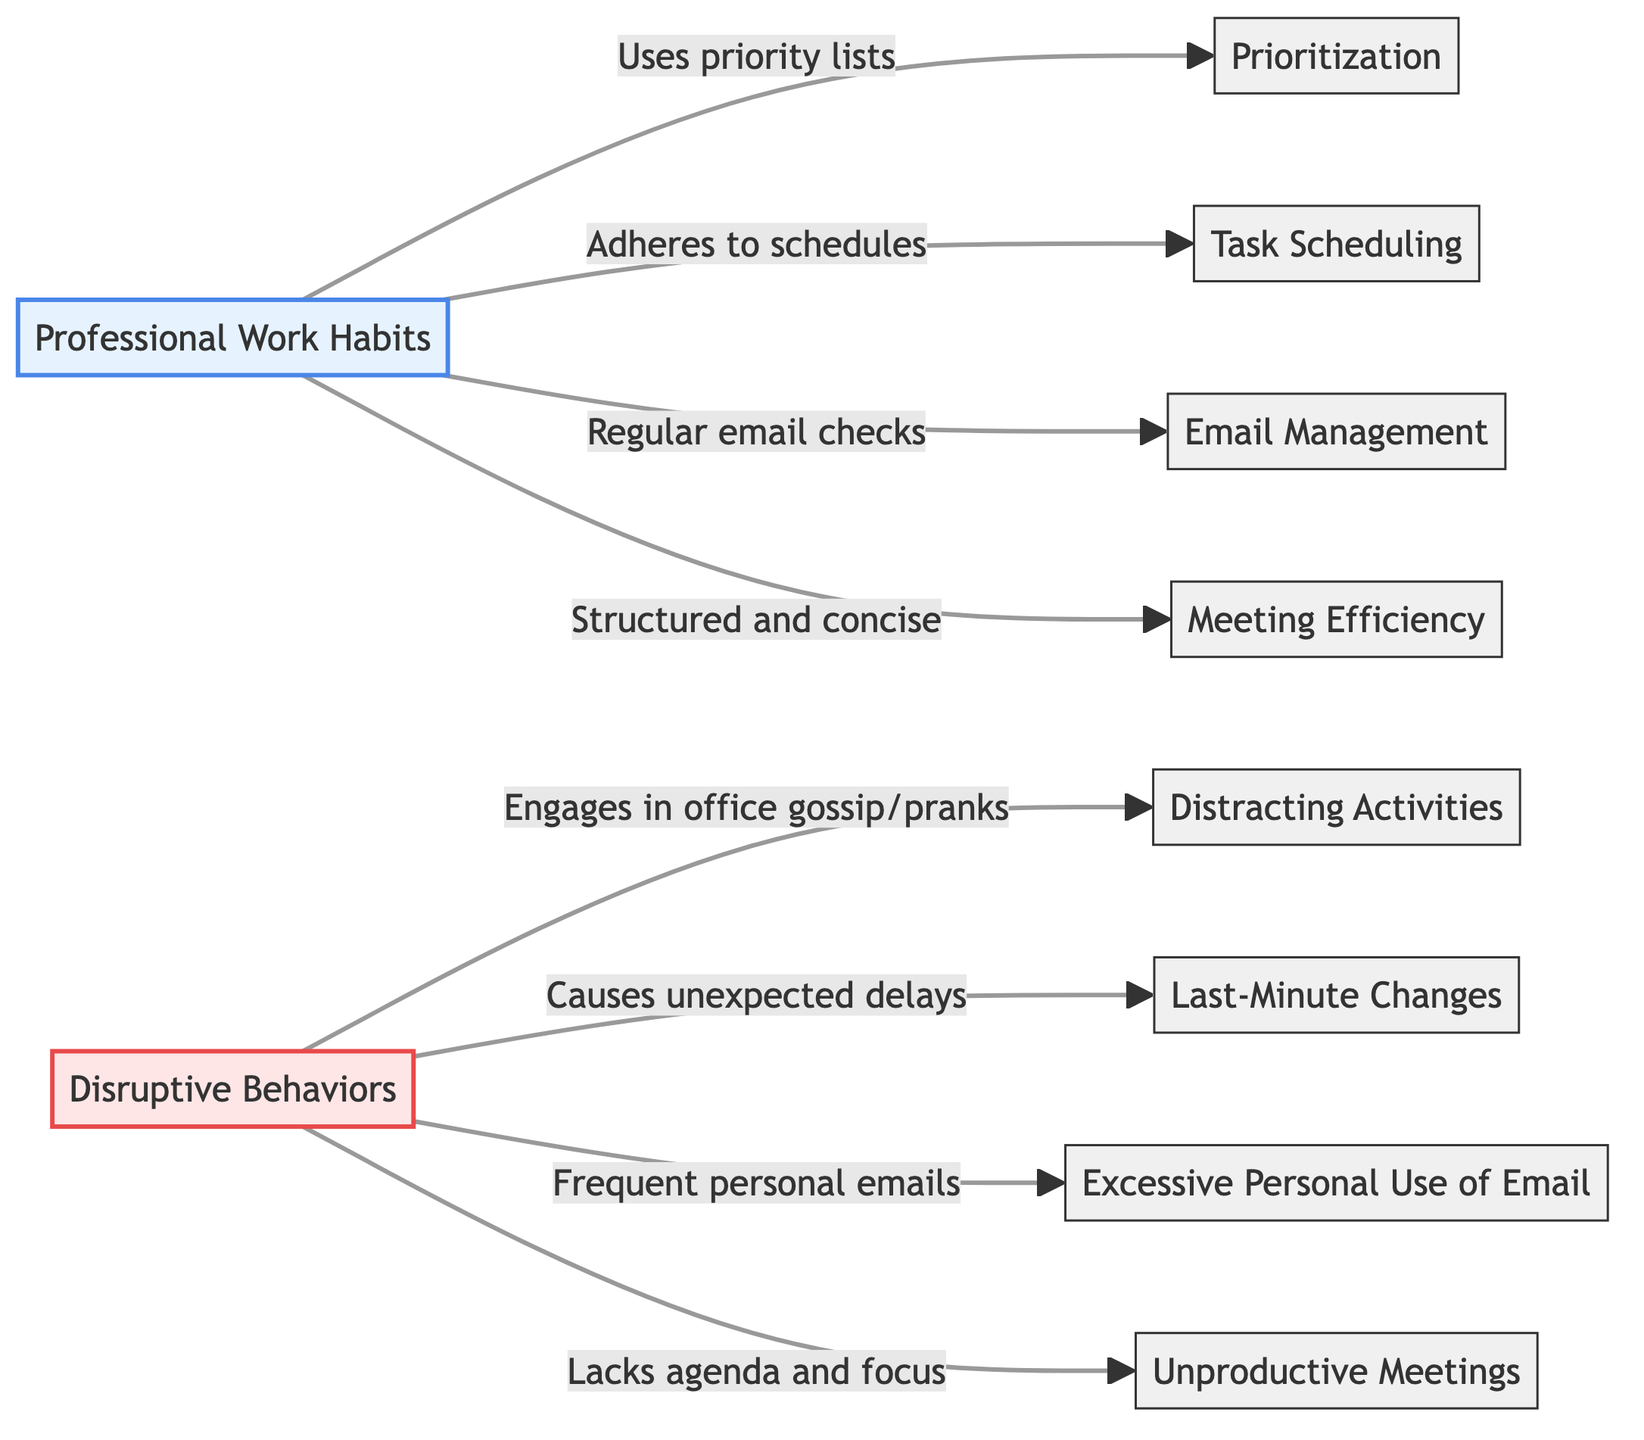What are the two main categories shown in the diagram? The diagram categorizes behaviors into "Professional Work Habits" and "Disruptive Behaviors." These represent the contrasting approaches to work within the workplace context.
Answer: Professional Work Habits, Disruptive Behaviors Which professional habit is associated with regular email checks? The diagram indicates that "Email Management" is the professional habit that corresponds to regular email checks. This is explicitly stated as part of the professional work habits.
Answer: Email Management How many specific habits and behaviors are illustrated in total? There are six professional work habits and four disruptive behaviors illustrated, adding up to a total of ten specific habits and behaviors in the diagram. This includes both categories combined.
Answer: Ten Which disruptive behavior is linked to unexpected delays? The diagram identifies "Last-Minute Changes" as the disruptive behavior that causes unexpected delays, showing how that specific behavior can be detrimental to workplace efficiency.
Answer: Last-Minute Changes What is the relationship between 'Prioritization' and 'Uses priority lists'? The diagram shows a direct association, stating that 'Prioritization' is a professional work habit that "Uses priority lists," indicating that this habit involves prioritizing tasks methodically.
Answer: Uses priority lists What type of meetings is indicated as unproductive? According to the diagram, 'Unproductive Meetings' are characterized by a "Lacks agenda and focus" relationship with disruptive behaviors, implying that these meetings do not effectively utilize time and resources.
Answer: Unproductive Meetings What connection exists between 'Task Scheduling' and professional habits? 'Task Scheduling' is depicted in the diagram as a professional work habit that relates to "Adheres to schedules." This connection highlights the importance of planning and adhering to a structured timeline for tasks.
Answer: Adheres to schedules Which disruptive behavior is associated with excessive personal use of email? The diagram specifies that the disruptive behavior "Excessive Personal Use of Email" is directly mentioned, linking this behavior to the impact it has on professional productivity in the workplace.
Answer: Excessive Personal Use of Email How do professional meetings compare with unproductive meetings according to the diagram? The diagram contrasts 'Meeting Efficiency’ with ‘Unproductive Meetings’, indicating that professional meetings are structured and concise, whereas unproductive ones lack focus and agenda, showing a significant difference in effectiveness.
Answer: Structured and concise vs. Lacks agenda and focus 